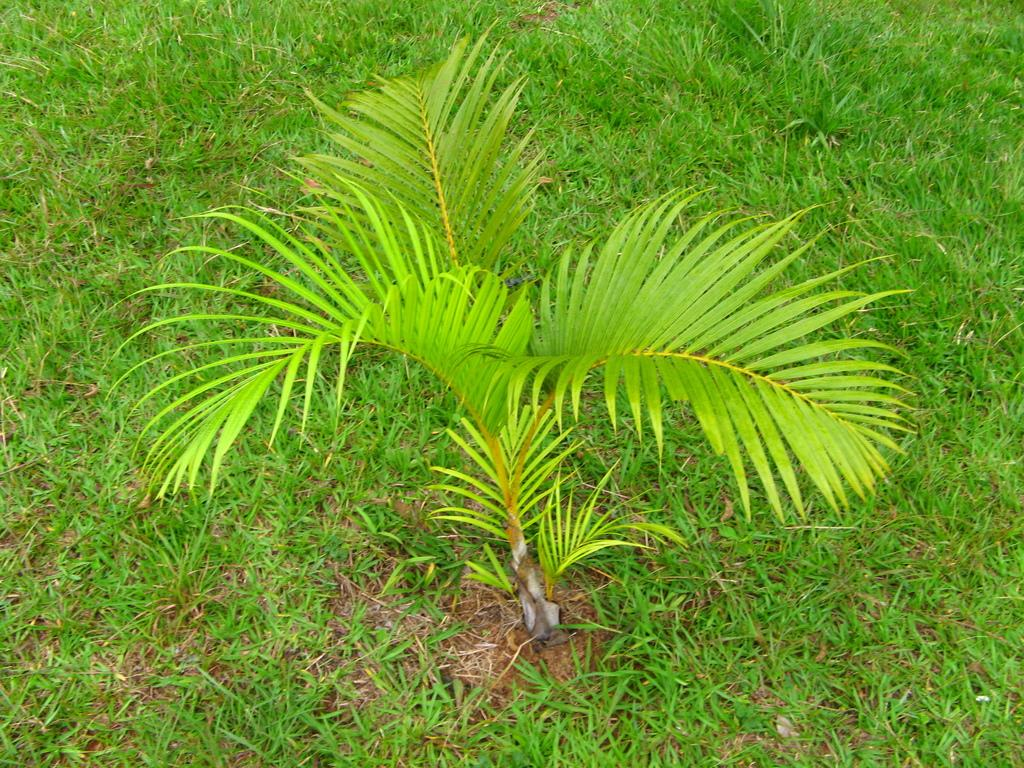What type of landscape is depicted in the image? There is a grassland in the image. Can you describe any specific features of the grassland? There is a plant in the middle of the grassland. Who is the owner of the army seen in the image? There is no army present in the image; it features a grassland with a plant in the middle. 